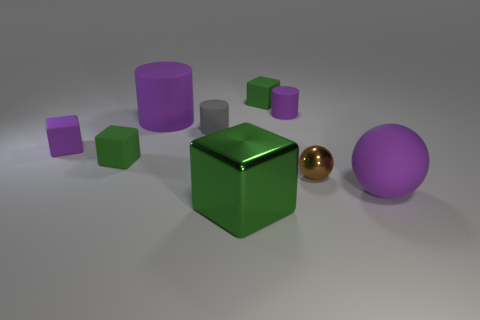What number of big gray cylinders are there?
Provide a succinct answer. 0. There is a large rubber object that is on the left side of the tiny cylinder behind the gray matte thing; what is its color?
Offer a very short reply. Purple. There is a matte cylinder that is the same size as the purple rubber ball; what is its color?
Provide a succinct answer. Purple. Are there any big matte balls of the same color as the big cylinder?
Give a very brief answer. Yes. Is there a tiny cyan sphere?
Provide a short and direct response. No. There is a tiny purple matte thing in front of the tiny gray cylinder; what shape is it?
Give a very brief answer. Cube. How many things are both in front of the big cylinder and behind the big sphere?
Keep it short and to the point. 4. What number of other objects are there of the same size as the brown ball?
Ensure brevity in your answer.  5. There is a big thing right of the green metallic thing; does it have the same shape as the metallic object to the right of the metallic block?
Give a very brief answer. Yes. What number of things are either tiny purple rubber cylinders or small green matte cubes behind the small brown shiny thing?
Make the answer very short. 3. 